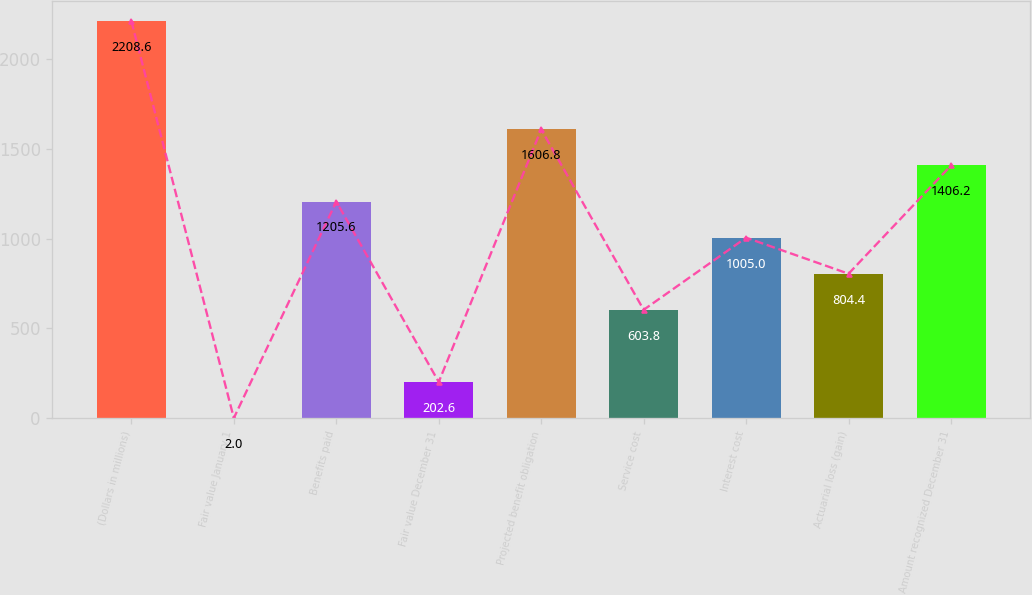Convert chart. <chart><loc_0><loc_0><loc_500><loc_500><bar_chart><fcel>(Dollars in millions)<fcel>Fair value January 1<fcel>Benefits paid<fcel>Fair value December 31<fcel>Projected benefit obligation<fcel>Service cost<fcel>Interest cost<fcel>Actuarial loss (gain)<fcel>Amount recognized December 31<nl><fcel>2208.6<fcel>2<fcel>1205.6<fcel>202.6<fcel>1606.8<fcel>603.8<fcel>1005<fcel>804.4<fcel>1406.2<nl></chart> 